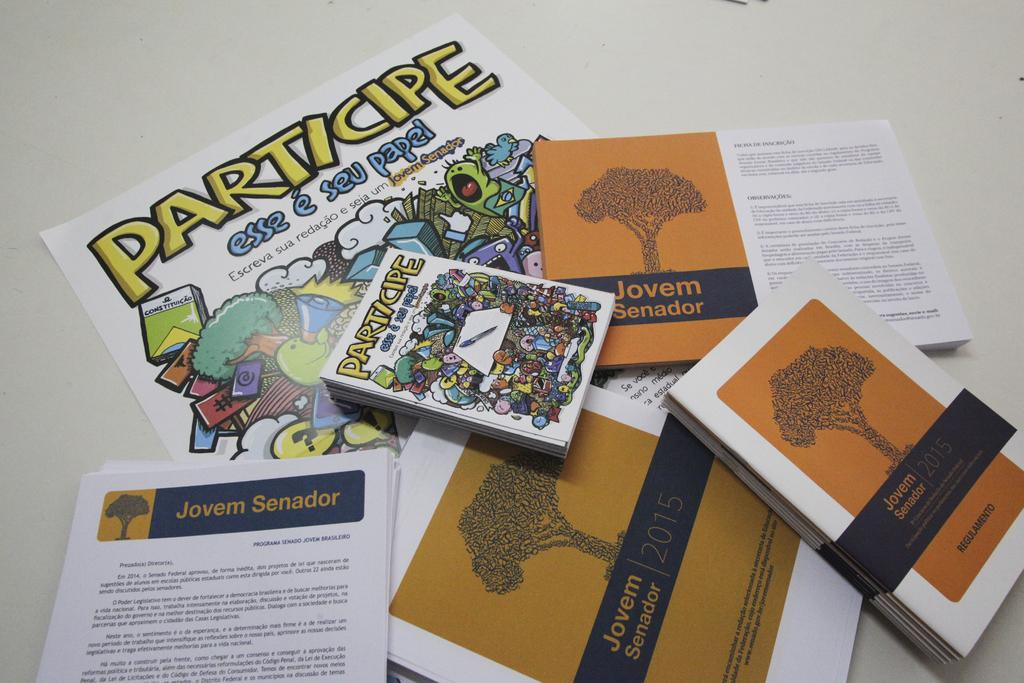<image>
Provide a brief description of the given image. A pile of pamplets written in spanish about Jovem Senador information. 